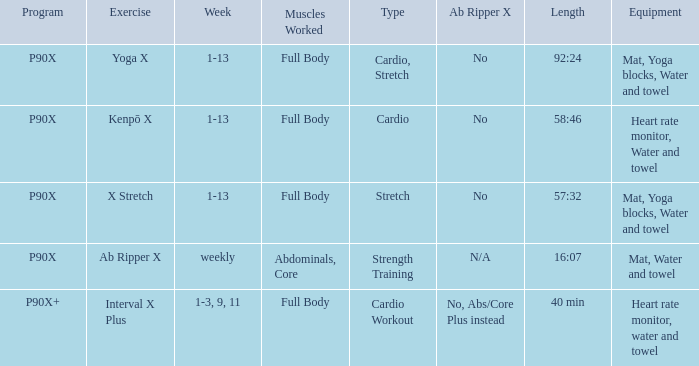What is the exercise when the equipment is heart rate monitor, water and towel? Kenpō X, Interval X Plus. 